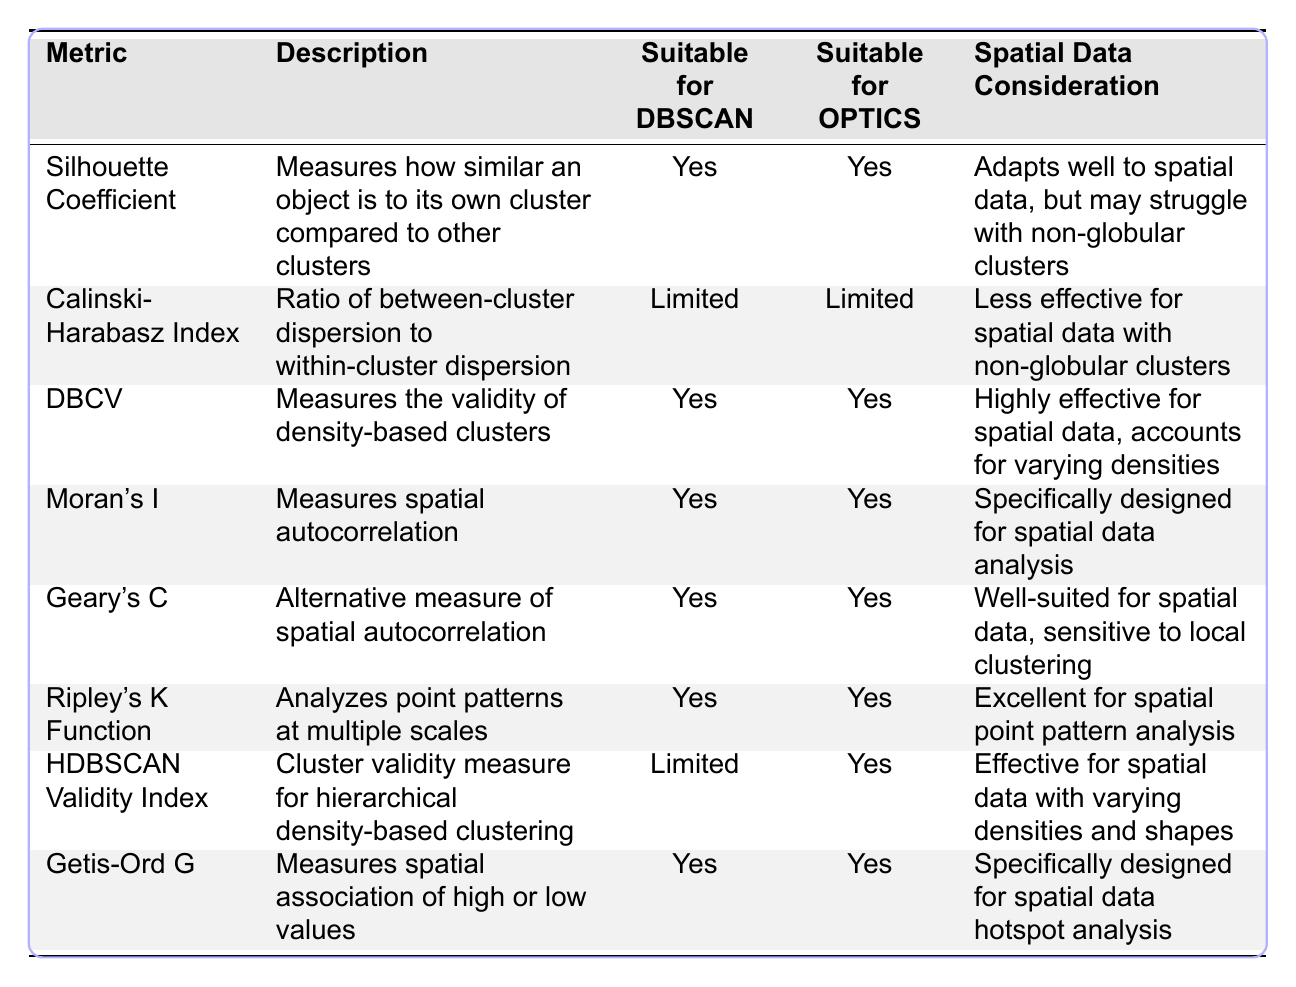What is the Silhouette Coefficient used to measure? The Silhouette Coefficient measures how similar an object is to its own cluster compared to other clusters, which is described in the table.
Answer: Similarity to own cluster vs. other clusters Is the Calinski-Harabasz Index suitable for DBSCAN? The table states that the suitability of the Calinski-Harabasz Index for DBSCAN is limited.
Answer: Limited Which metrics are suitable for both DBSCAN and OPTICS? By inspecting the table, several metrics, including Silhouette Coefficient, DBCV, Moran's I, Geary's C, Ripley's K Function, Getis-Ord G, and HDBSCAN Validity Index, are identified as suitable for both algorithms.
Answer: Silhouette Coefficient, DBCV, Moran's I, Geary's C, Ripley's K Function, Getis-Ord G, HDBSCAN Validity Index What is the main advantage of the DBCV metric as per the table? The table indicates that DBCV measures the validity of density-based clusters and is highly effective for spatial data, balancing for varying densities.
Answer: Validity of clusters; effective for varying densities Determine which metrics measure spatial autocorrelation. From the table, both Moran's I and Geary's C are identified as metrics that measure spatial autocorrelation based on their descriptions.
Answer: Moran's I, Geary's C Does the HDBSCAN Validity Index account for varying densities in spatial data? The HDBSCAN Validity Index is noted in the table to be effective for spatial data with varying densities and shapes, indicating it does account for these variations.
Answer: Yes How many metrics are limited in suitability for DBSCAN? Reviewing the table, two metrics (Calinski-Harabasz Index and HDBSCAN Validity Index) are labeled as limited in suitability for DBSCAN, which requires simple counting of those metrics.
Answer: Two Which metric specifically targets hotspot analysis in spatial data? The table specifies that the Getis-Ord G metric is designed for spatial data hotspot analysis, directly answering the question regarding the target of this metric.
Answer: Getis-Ord G What does Ripley's K Function analyze? The table describes Ripley's K Function as an analyzer of point patterns at multiple scales, indicating its role in a broader spatial context.
Answer: Point patterns at multiple scales Which metric has a well-suited nature for local clustering as per the explanation in the table? Based on the table content, Geary's C is noted for being sensitive to local clustering, suggesting its appropriateness for examining local clustering effects.
Answer: Geary's C 